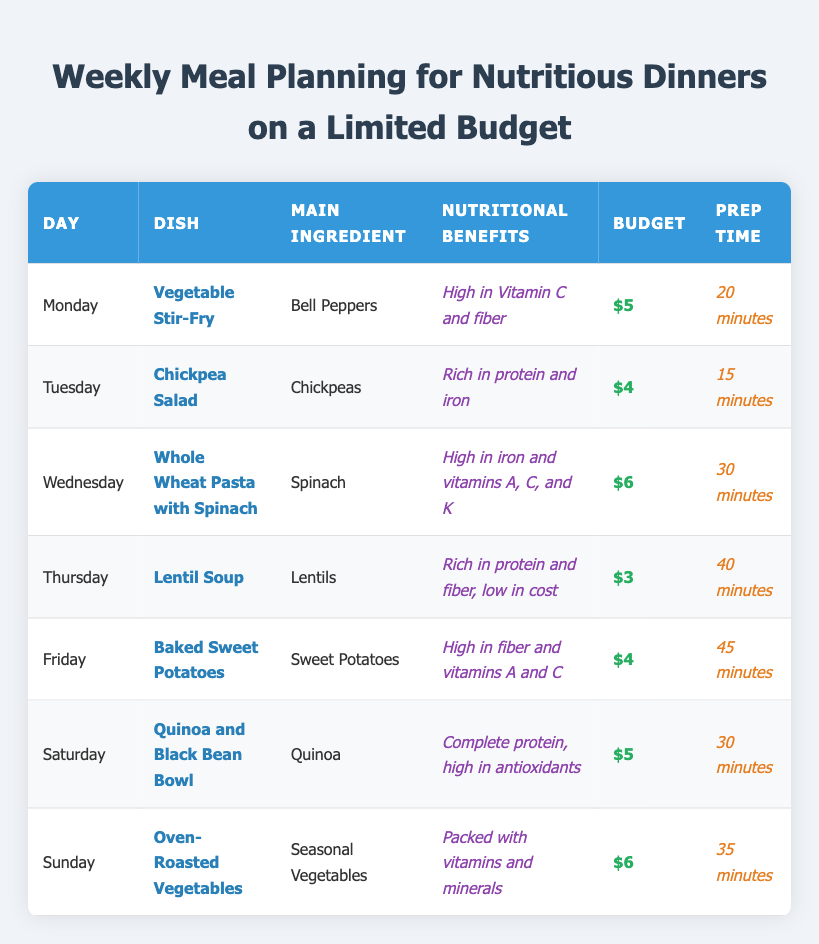What is the dish planned for Thursday? By looking at the table under the column for the day "Thursday," we can see the dish is "Lentil Soup."
Answer: Lentil Soup Which dish is the most affordable? The least budgeted dish in the table is "Lentil Soup," which costs $3.
Answer: Lentil Soup What is the total budget for the week? Adding up the budgets from each day: $5 + $4 + $6 + $3 + $4 + $5 + $6 equals $33.
Answer: $33 What is the average prep time for the dinners listed? To find the average prep time, add the prep times: 20 + 15 + 30 + 40 + 45 + 30 + 35 = 215 minutes. Divide by the number of meals (7): 215 / 7 ≈ 30.71. The average prep time is approximately 31 minutes.
Answer: 31 minutes On which day is the dish "Whole Wheat Pasta with Spinach" scheduled? Looking at the table, "Whole Wheat Pasta with Spinach" is listed under "Wednesday."
Answer: Wednesday Do any of the dishes exceed a budget of $5? Checking the budget column, we see "Wednesday" and "Sunday" both have dishes priced at $6, which exceed $5. So, yes, some dishes exceed that budget.
Answer: Yes What is the main ingredient used for the dish on Saturday? Referring to the table, the main ingredient for the dish on "Saturday," which is "Quinoa and Black Bean Bowl," is "Quinoa."
Answer: Quinoa Is the dish with the lowest budget also rich in protein? The dish with the lowest budget is "Lentil Soup," which is described as rich in protein and fiber. So, yes, it matches both criteria.
Answer: Yes How many dishes are prepared in under 30 minutes? Looking at the prep times, both "Chickpea Salad" (15 minutes) and "Vegetable Stir-Fry" (20 minutes) are under 30 minutes, which means there are 2 dishes.
Answer: 2 dishes What are the nutritional benefits of the dish on Tuesday? The nutritional benefits listed for "Chickpea Salad" on "Tuesday" indicate it is "Rich in protein and iron."
Answer: Rich in protein and iron 